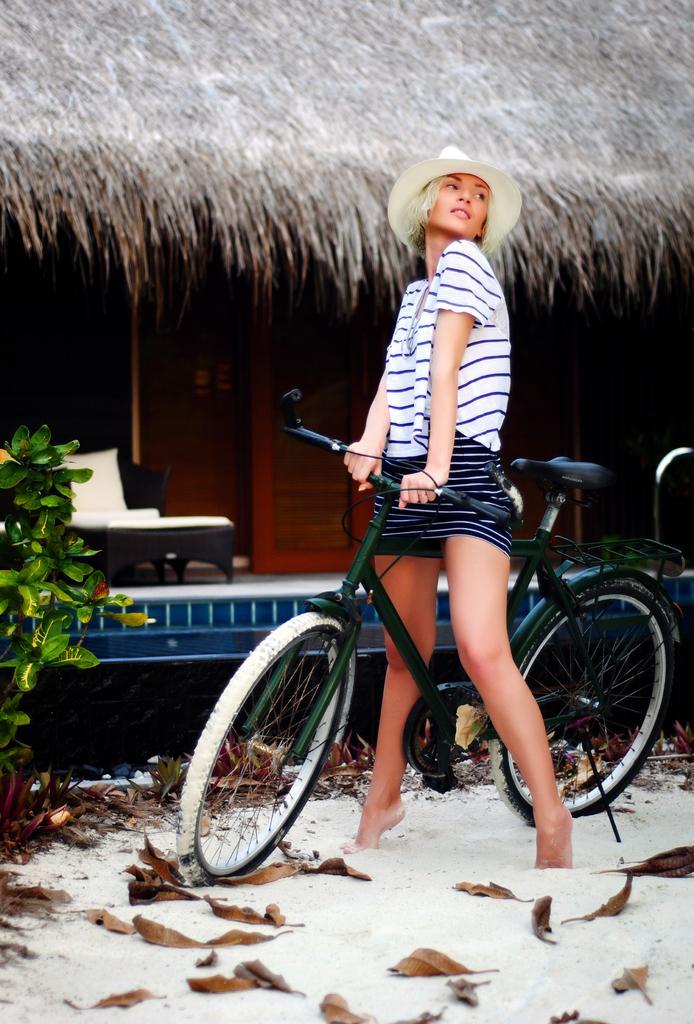How would you summarize this image in a sentence or two? This person standing and holding bicycle. This is sand. On the background we can see bed. This is plant. 